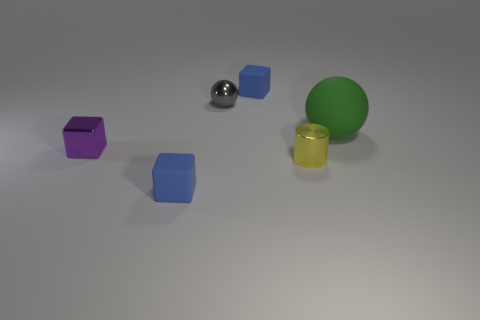Subtract all tiny shiny blocks. How many blocks are left? 2 Subtract all gray spheres. How many spheres are left? 1 Add 2 big yellow matte cubes. How many objects exist? 8 Subtract 2 blocks. How many blocks are left? 1 Subtract all cylinders. How many objects are left? 5 Add 1 purple objects. How many purple objects are left? 2 Add 5 big purple metallic blocks. How many big purple metallic blocks exist? 5 Subtract 0 yellow cubes. How many objects are left? 6 Subtract all purple cylinders. Subtract all yellow balls. How many cylinders are left? 1 Subtract all blue blocks. How many blue cylinders are left? 0 